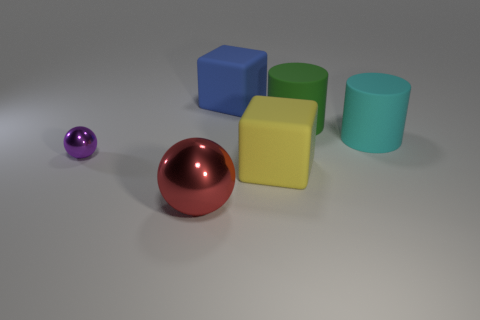Is there anything else that is the same size as the purple metal ball?
Your answer should be compact. No. What material is the cube in front of the big matte block behind the matte cube in front of the large green object?
Your answer should be very brief. Rubber. Does the big thing that is to the left of the blue object have the same shape as the small thing?
Keep it short and to the point. Yes. There is a large cube that is behind the cyan cylinder; what is it made of?
Your response must be concise. Rubber. How many matte objects are either large yellow blocks or tiny gray objects?
Your answer should be compact. 1. Are there any other matte blocks of the same size as the yellow matte block?
Your answer should be compact. Yes. Are there more large objects that are to the left of the blue rubber block than tiny green metal objects?
Keep it short and to the point. Yes. What number of small things are either gray things or cyan matte objects?
Offer a terse response. 0. How many other big rubber things are the same shape as the cyan object?
Make the answer very short. 1. There is a large cube left of the large matte block that is in front of the tiny purple metal thing; what is it made of?
Provide a succinct answer. Rubber. 